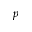Convert formula to latex. <formula><loc_0><loc_0><loc_500><loc_500>p</formula> 